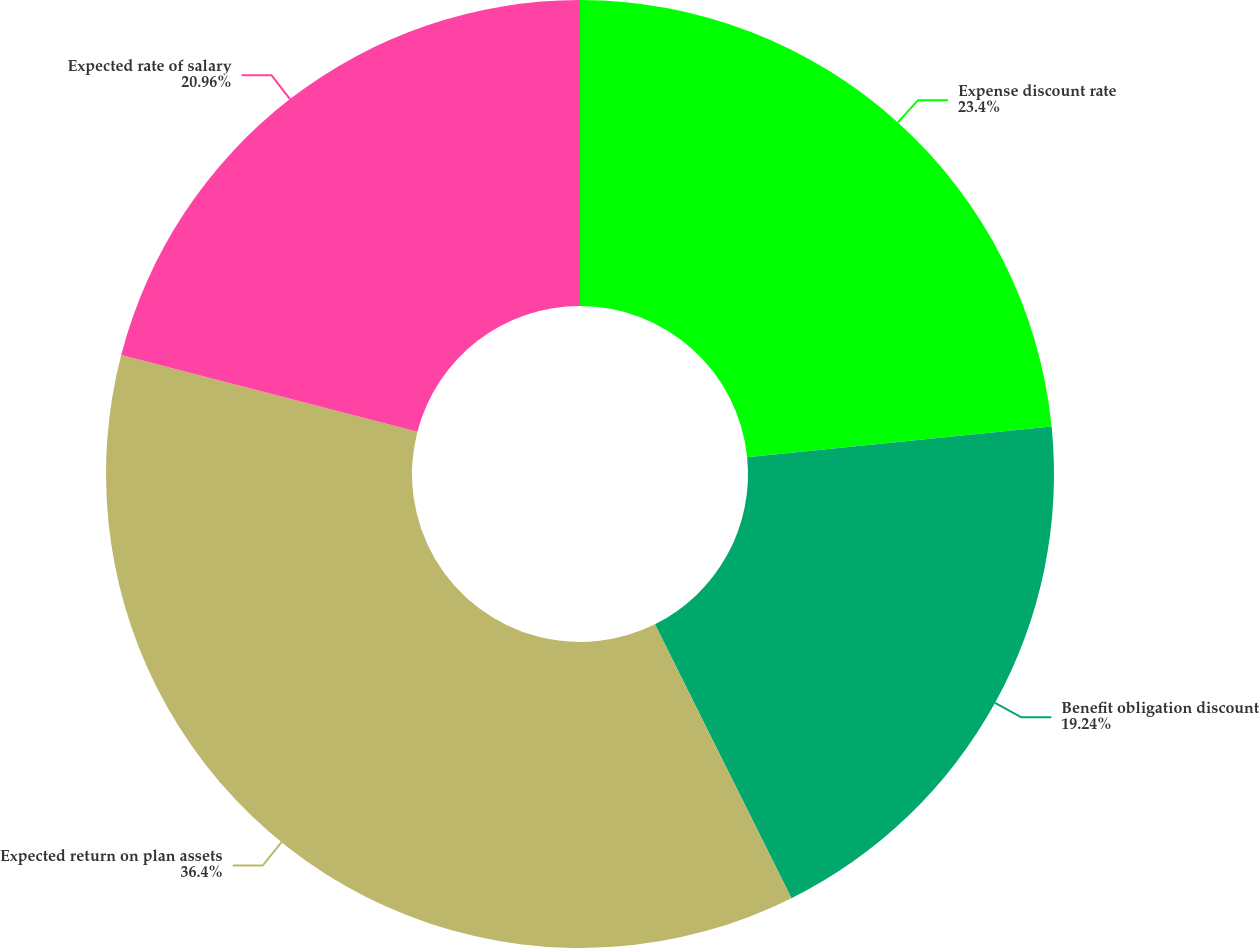Convert chart. <chart><loc_0><loc_0><loc_500><loc_500><pie_chart><fcel>Expense discount rate<fcel>Benefit obligation discount<fcel>Expected return on plan assets<fcel>Expected rate of salary<nl><fcel>23.4%<fcel>19.24%<fcel>36.4%<fcel>20.96%<nl></chart> 